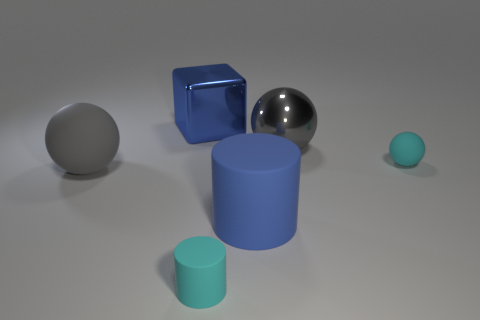Are there any other things that are the same shape as the big gray metallic thing?
Keep it short and to the point. Yes. Does the large thing to the left of the blue cube have the same color as the cylinder that is to the right of the cyan cylinder?
Your answer should be very brief. No. Are there any large things?
Keep it short and to the point. Yes. There is a tiny object that is the same color as the tiny matte ball; what material is it?
Your answer should be very brief. Rubber. What is the size of the rubber ball that is on the left side of the cyan matte ball that is on the right side of the large blue object that is to the left of the small cylinder?
Provide a succinct answer. Large. Do the blue metallic object and the cyan thing on the left side of the cyan rubber ball have the same shape?
Offer a terse response. No. Is there another metallic sphere that has the same color as the large metal sphere?
Make the answer very short. No. How many cubes are blue objects or large brown shiny things?
Your response must be concise. 1. Is there another blue thing that has the same shape as the blue metal object?
Ensure brevity in your answer.  No. Is the number of gray shiny spheres that are left of the big cube less than the number of big rubber spheres?
Offer a very short reply. Yes. 